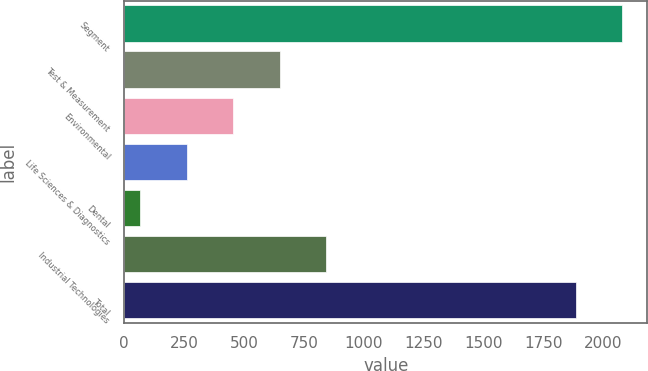Convert chart to OTSL. <chart><loc_0><loc_0><loc_500><loc_500><bar_chart><fcel>Segment<fcel>Test & Measurement<fcel>Environmental<fcel>Life Sciences & Diagnostics<fcel>Dental<fcel>Industrial Technologies<fcel>Total<nl><fcel>2081.3<fcel>648.9<fcel>454.6<fcel>260.3<fcel>66<fcel>843.2<fcel>1887<nl></chart> 